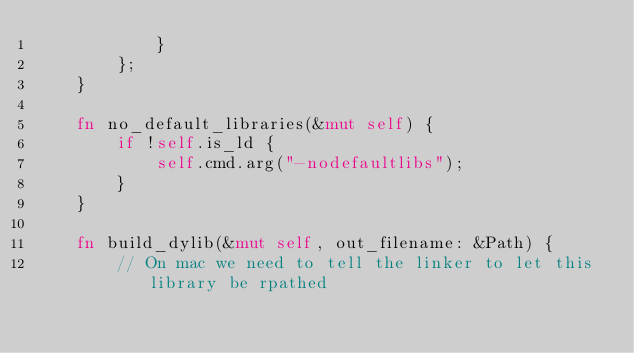<code> <loc_0><loc_0><loc_500><loc_500><_Rust_>            }
        };
    }

    fn no_default_libraries(&mut self) {
        if !self.is_ld {
            self.cmd.arg("-nodefaultlibs");
        }
    }

    fn build_dylib(&mut self, out_filename: &Path) {
        // On mac we need to tell the linker to let this library be rpathed</code> 